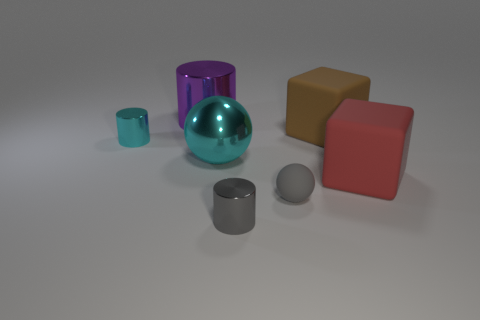Subtract all big cylinders. How many cylinders are left? 2 Add 3 tiny gray metal things. How many objects exist? 10 Subtract all green cylinders. Subtract all cyan spheres. How many cylinders are left? 3 Subtract all things. Subtract all large green rubber blocks. How many objects are left? 0 Add 5 large red rubber cubes. How many large red rubber cubes are left? 6 Add 5 big green shiny cubes. How many big green shiny cubes exist? 5 Subtract 1 red blocks. How many objects are left? 6 Subtract all cylinders. How many objects are left? 4 